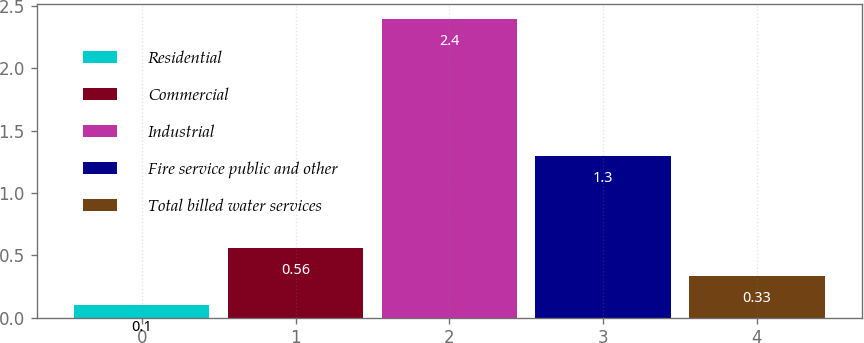Convert chart. <chart><loc_0><loc_0><loc_500><loc_500><bar_chart><fcel>Residential<fcel>Commercial<fcel>Industrial<fcel>Fire service public and other<fcel>Total billed water services<nl><fcel>0.1<fcel>0.56<fcel>2.4<fcel>1.3<fcel>0.33<nl></chart> 